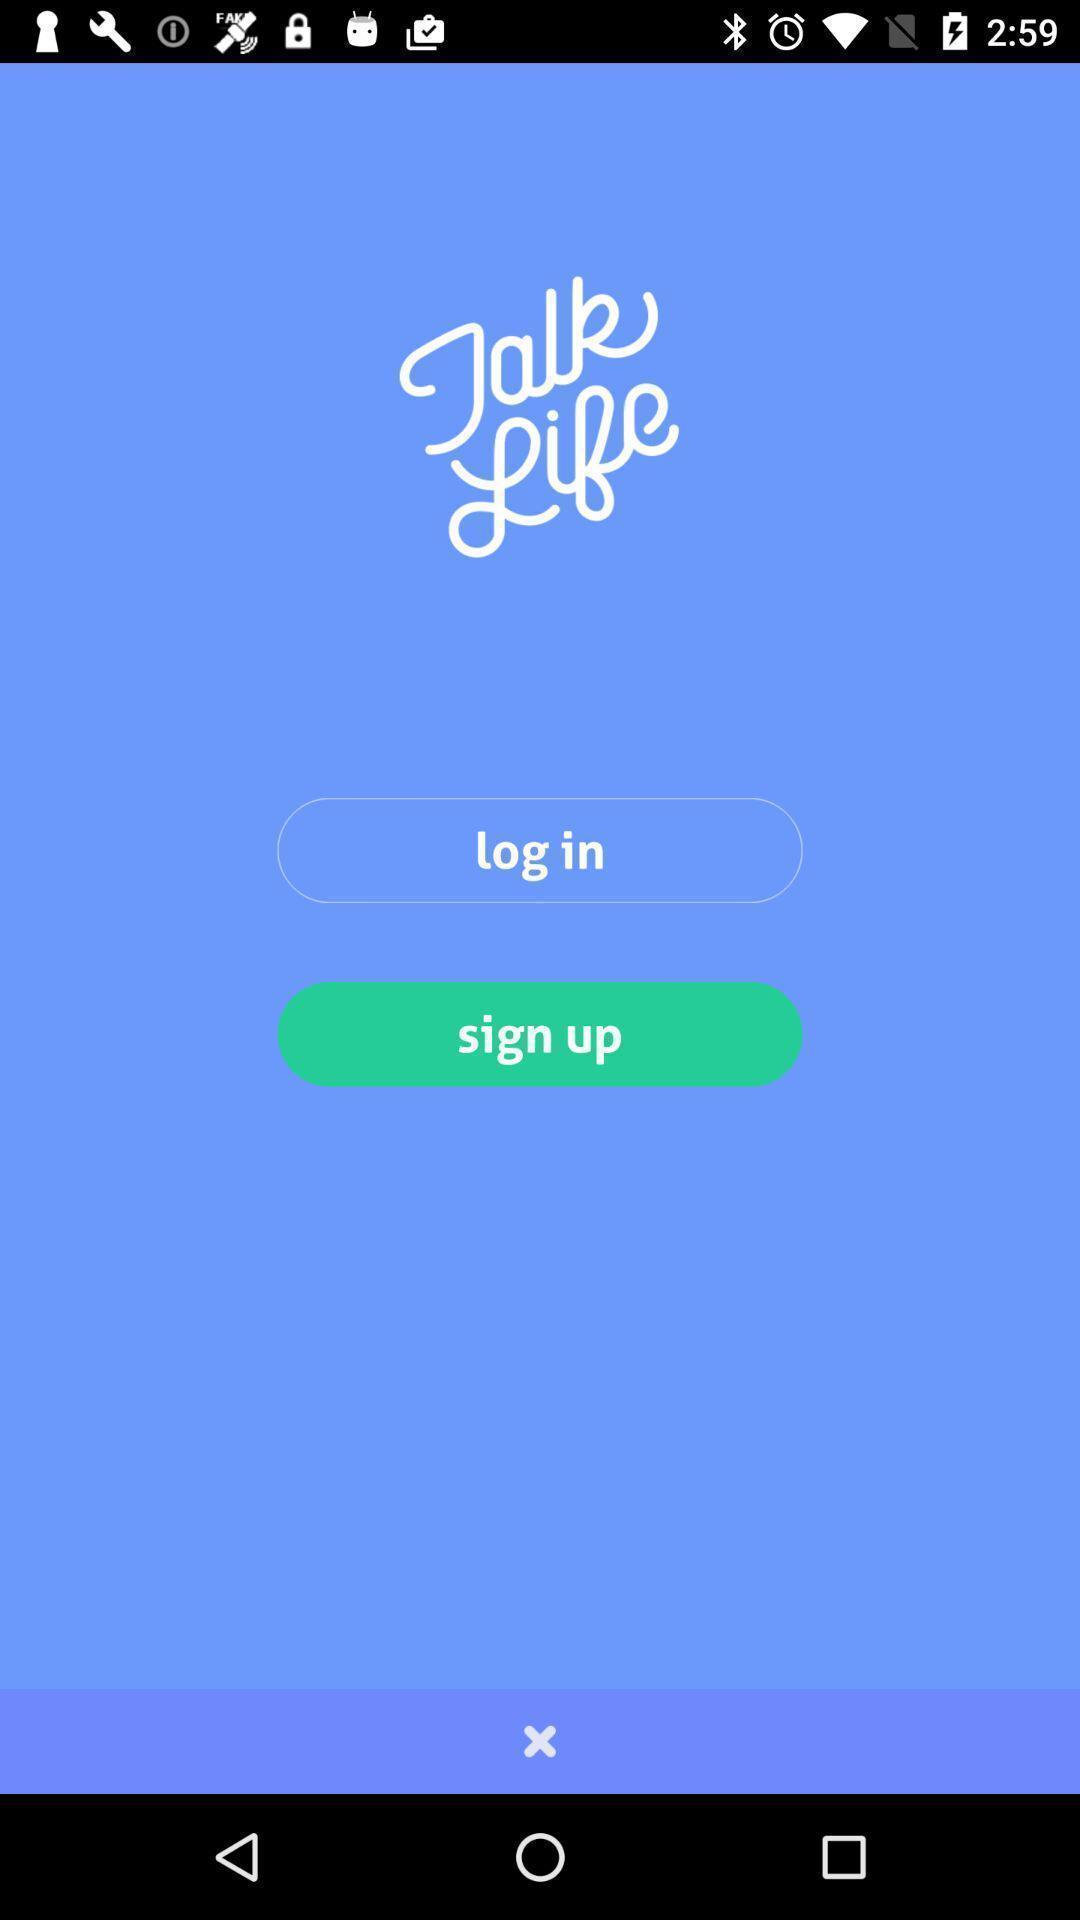Summarize the information in this screenshot. Welcome page of social app. 